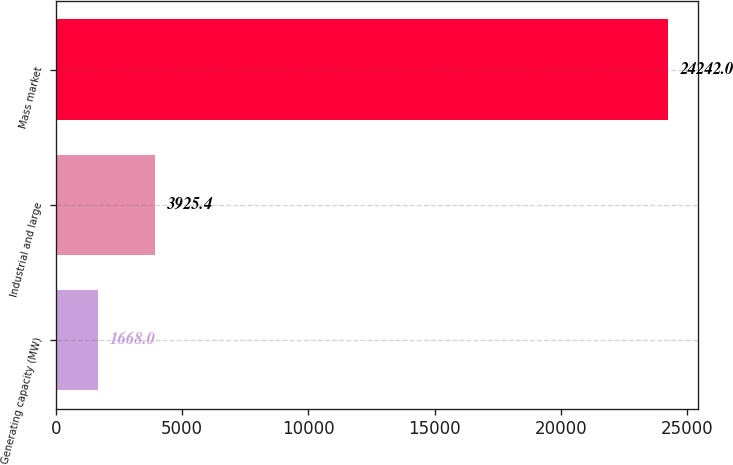<chart> <loc_0><loc_0><loc_500><loc_500><bar_chart><fcel>Generating capacity (MW)<fcel>Industrial and large<fcel>Mass market<nl><fcel>1668<fcel>3925.4<fcel>24242<nl></chart> 